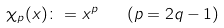Convert formula to latex. <formula><loc_0><loc_0><loc_500><loc_500>\chi _ { p } ( x ) \colon = x ^ { p } \quad ( p = 2 q - 1 )</formula> 